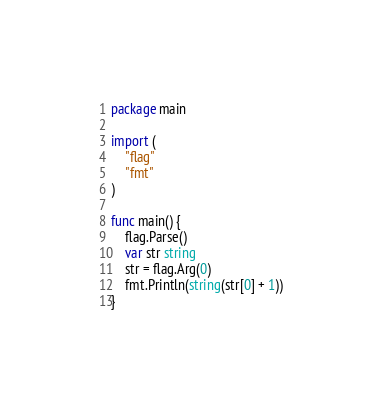<code> <loc_0><loc_0><loc_500><loc_500><_Go_>package main

import (
	"flag"
	"fmt"
)

func main() {
	flag.Parse()
	var str string
	str = flag.Arg(0)
	fmt.Println(string(str[0] + 1))
}
</code> 